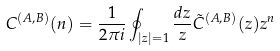<formula> <loc_0><loc_0><loc_500><loc_500>C ^ { ( A , B ) } ( n ) = \frac { 1 } { 2 \pi i } \oint _ { | z | = 1 } \frac { d z } { z } \tilde { C } ^ { ( A , B ) } ( z ) z ^ { n }</formula> 